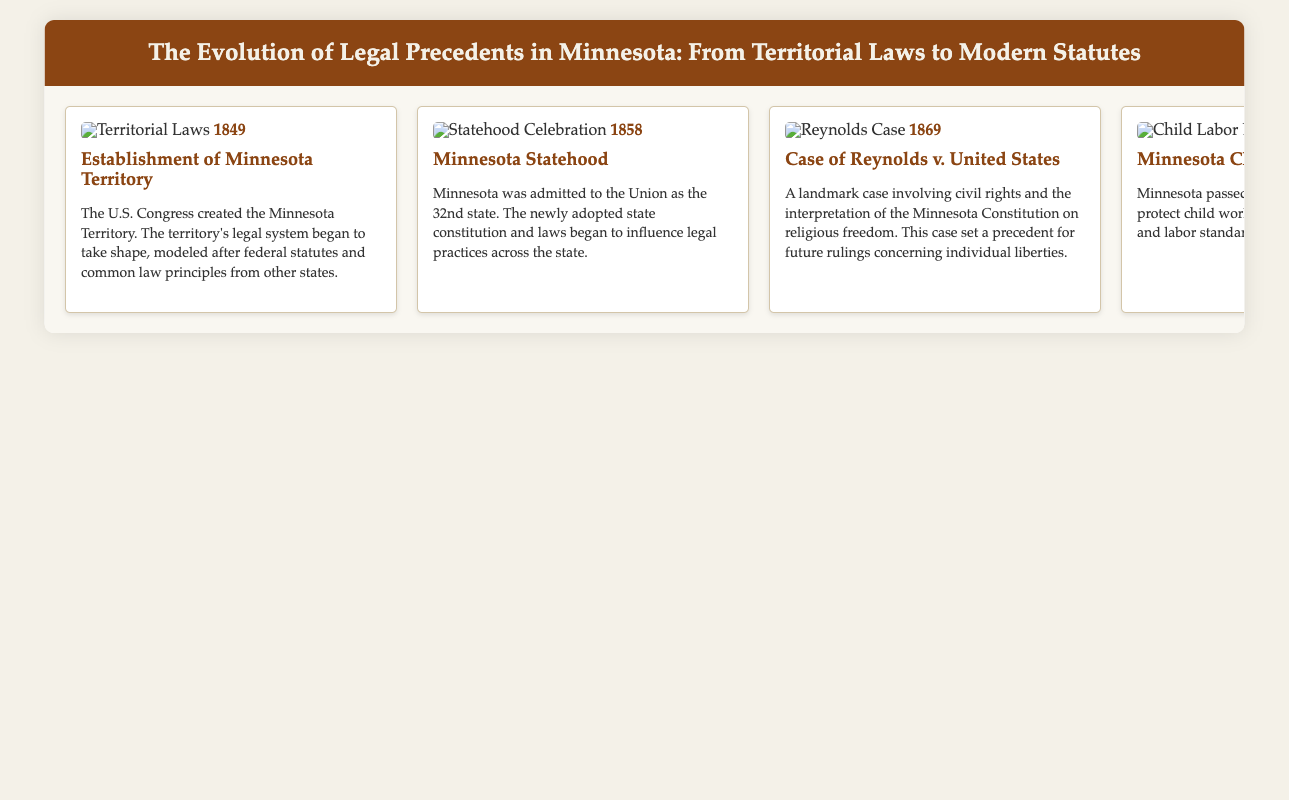What year was Minnesota established as a territory? The document states that Minnesota Territory was established in 1849.
Answer: 1849 What significant legal event occurred in 1858? The document mentions that Minnesota was admitted to the Union as the 32nd state in 1858.
Answer: Statehood What case in 1869 dealt with civil rights in Minnesota? The document refers to the Reynolds v. United States case as a landmark civil rights case in 1869.
Answer: Reynolds v. United States What was passed in Minnesota in 1921 to protect children? According to the document, Minnesota passed the Child Labor Law in 1921.
Answer: Child Labor Law In which year did the Reserve Mining Company case take place? The document lists the Reserve Mining Company v. EPA case occurring in 1972.
Answer: 1972 What does the 1993 case of Moore v. Minnesota Department of Public Safety concern? The document indicates that the Moore case related to administrative law and state agency authority.
Answer: Administrative law What architectural change occurred in 2020 in Minneapolis? The document highlights the modernization of courthouses in Minneapolis as a significant event in 2020.
Answer: Courthouse Modernization How many years are spanned in the timeline presented? The timeline covers events from 1849 to 2020, making the span 171 years.
Answer: 171 years What type of images are included in the timeline? The document mentions that notable historical images of courthouse architecture are included in the timeline.
Answer: Historical images 